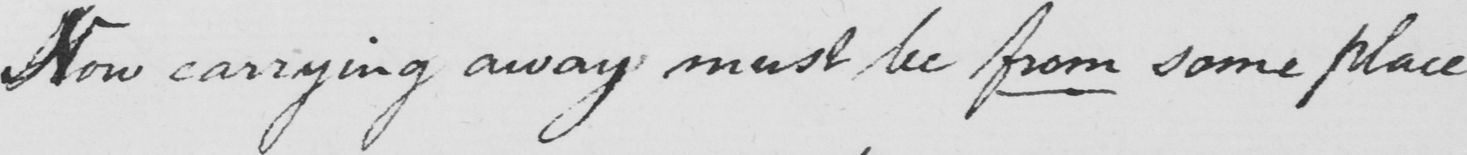What is written in this line of handwriting? Now carrying away must be from some place 